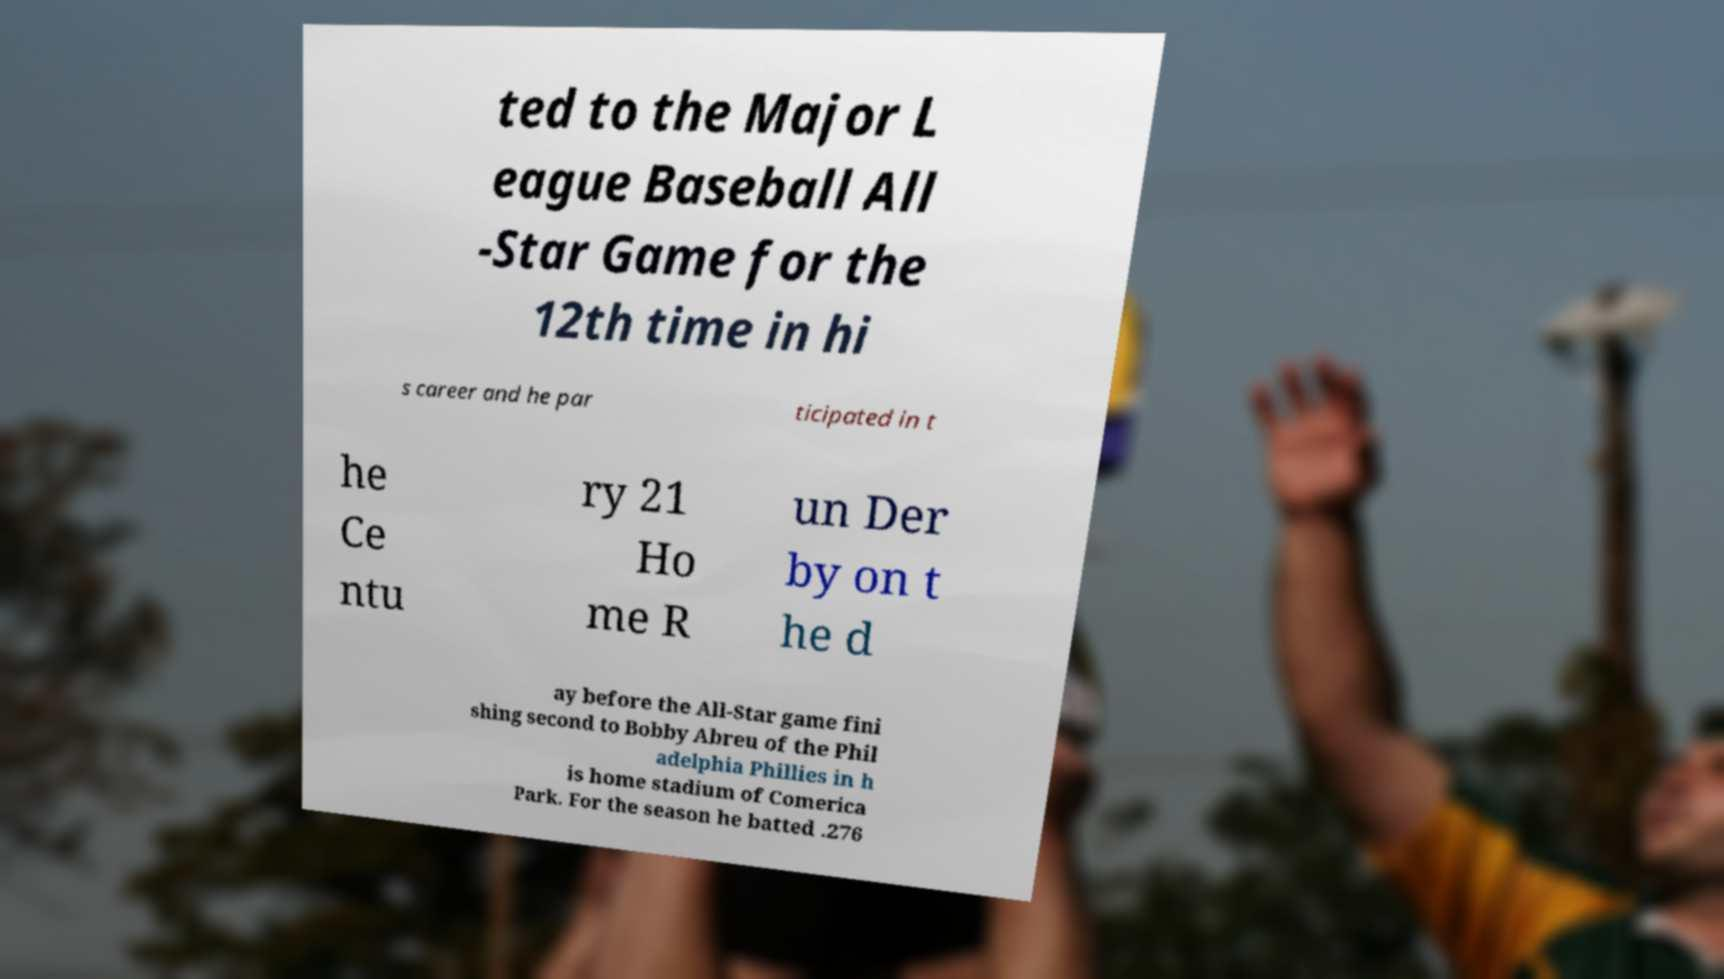For documentation purposes, I need the text within this image transcribed. Could you provide that? ted to the Major L eague Baseball All -Star Game for the 12th time in hi s career and he par ticipated in t he Ce ntu ry 21 Ho me R un Der by on t he d ay before the All-Star game fini shing second to Bobby Abreu of the Phil adelphia Phillies in h is home stadium of Comerica Park. For the season he batted .276 